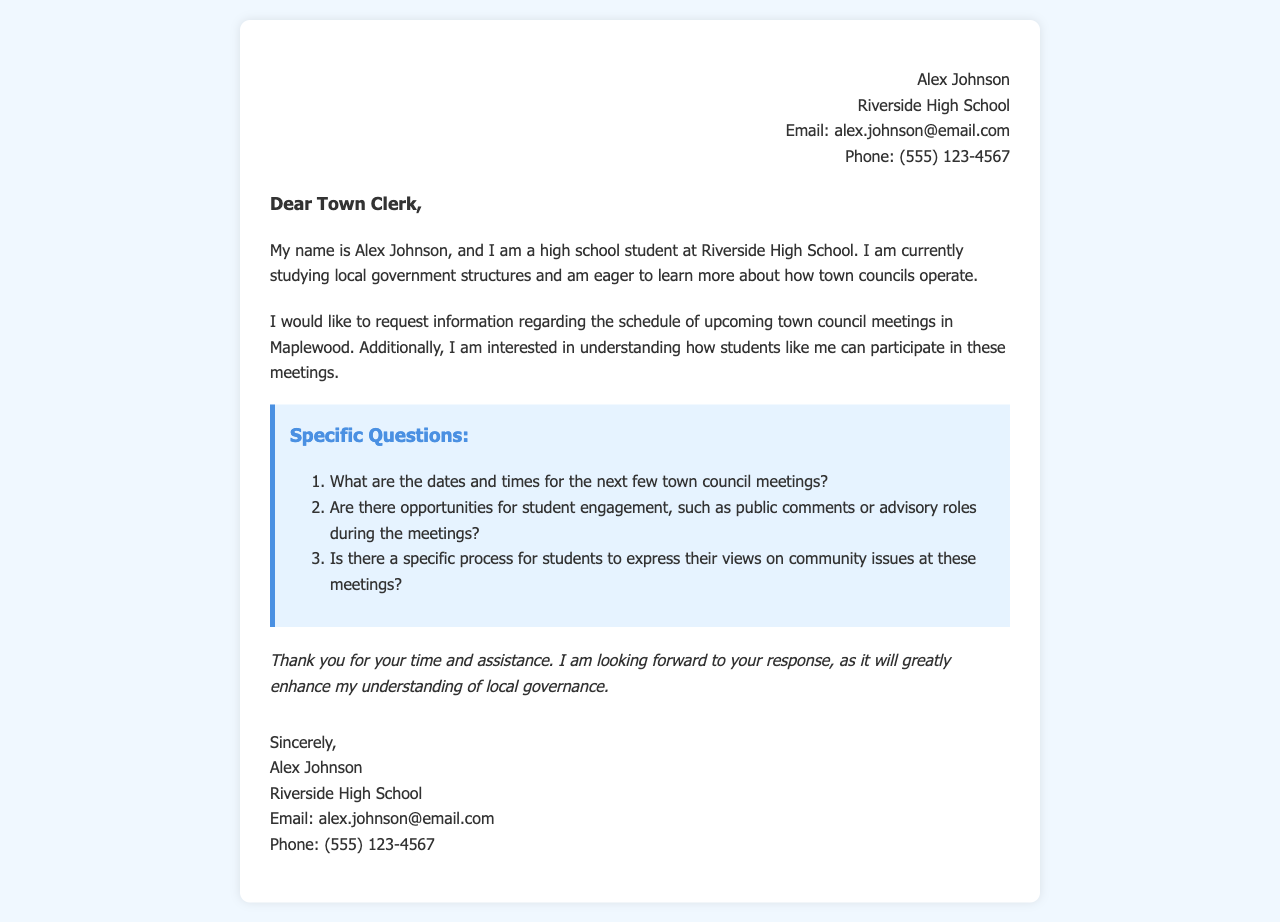What is the sender's name? The sender's name is mentioned at the beginning of the letter.
Answer: Alex Johnson What school does the sender attend? The sender states their school in the introduction of the letter.
Answer: Riverside High School What is one of the topics the sender is studying? The sender specifies their area of study in the letter.
Answer: Local government structures What does the sender request information about? The sender outlines their request in one of the sections of the letter.
Answer: Schedule of town council meetings How many specific questions does the sender ask? The number of questions is indicated in the section titled "Specific Questions."
Answer: Three What is the purpose of the sender's letter? The letter's purpose is conveyed in the opening paragraphs and is summarized in the conclusion.
Answer: To request information What are the contact details provided by the sender? The sender provides their contact details at the beginning and end of the letter.
Answer: Email and phone number Is there mention of student engagement opportunities? The sender explicitly asks about this in one of their specific questions.
Answer: Yes What is the closing phrase used in the letter? The closing phrase is a standard way to end formal letters.
Answer: Sincerely 